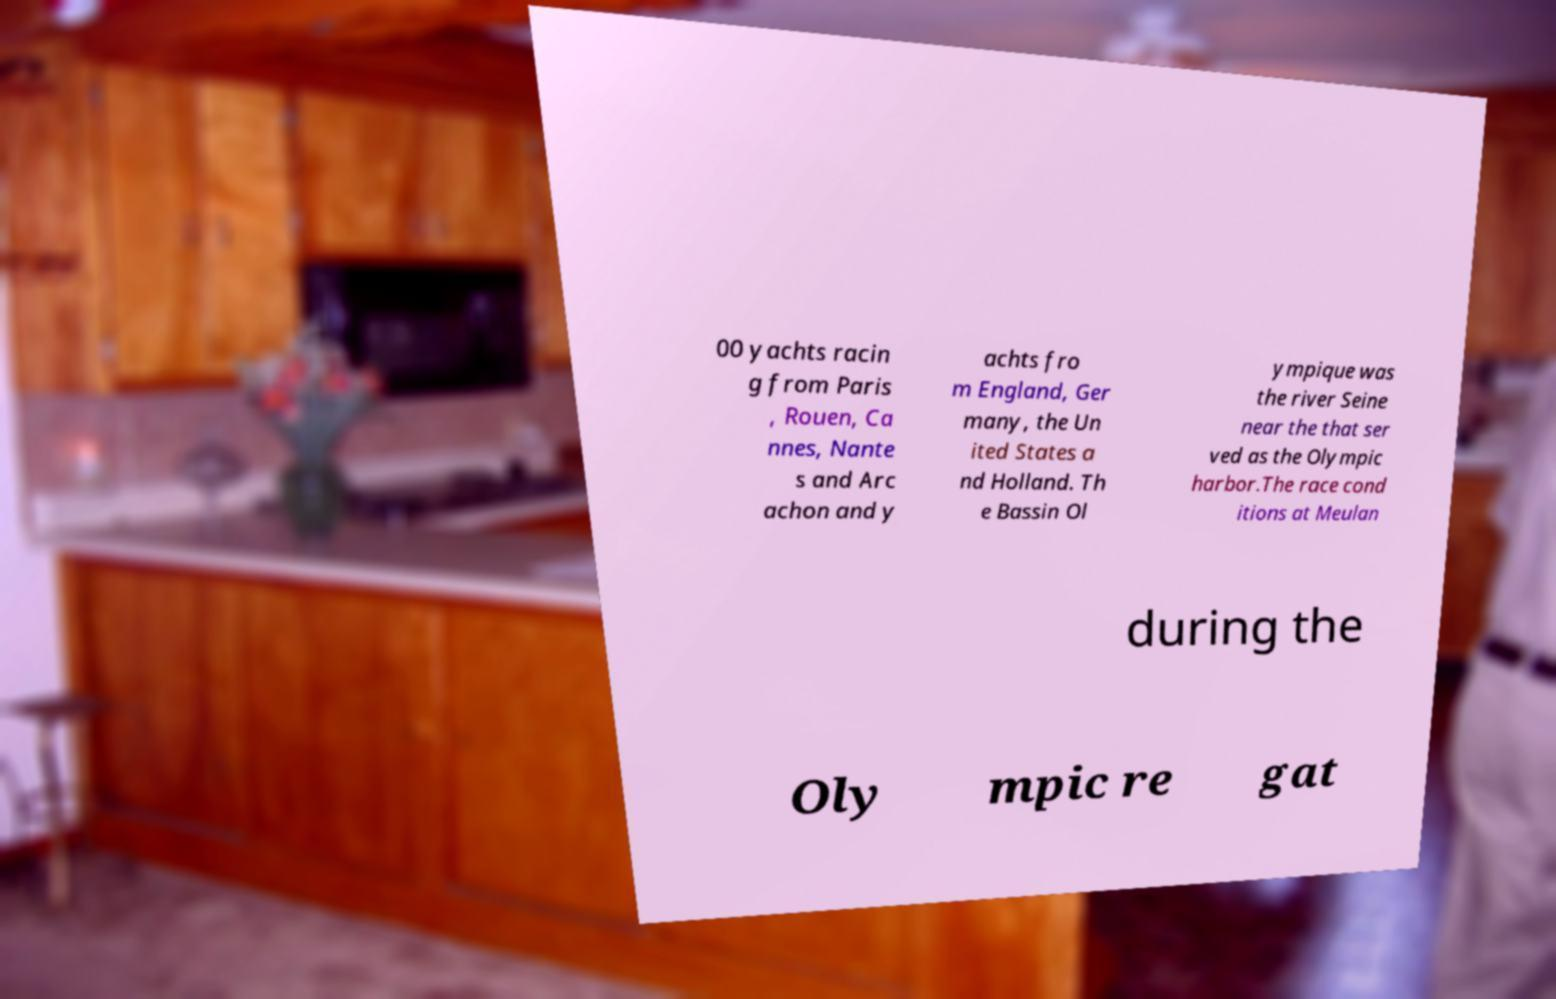For documentation purposes, I need the text within this image transcribed. Could you provide that? 00 yachts racin g from Paris , Rouen, Ca nnes, Nante s and Arc achon and y achts fro m England, Ger many, the Un ited States a nd Holland. Th e Bassin Ol ympique was the river Seine near the that ser ved as the Olympic harbor.The race cond itions at Meulan during the Oly mpic re gat 